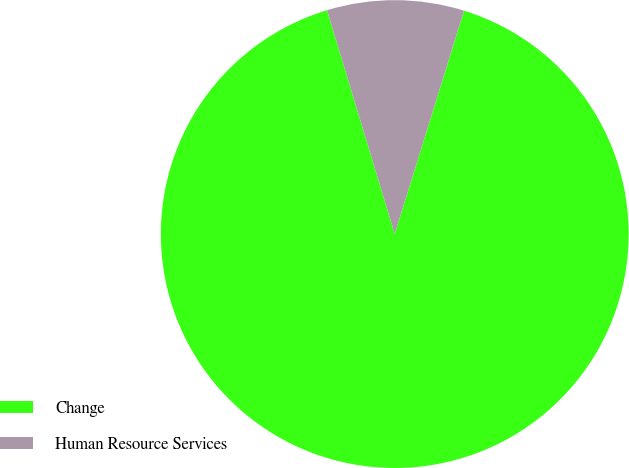<chart> <loc_0><loc_0><loc_500><loc_500><pie_chart><fcel>Change<fcel>Human Resource Services<nl><fcel>90.54%<fcel>9.46%<nl></chart> 